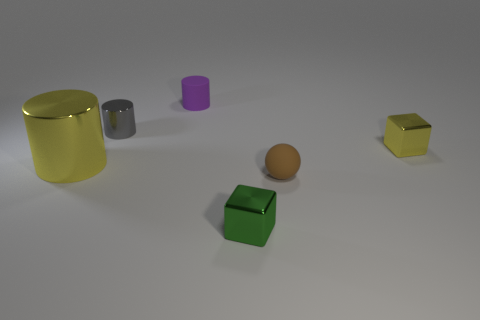Do the large thing and the tiny brown thing have the same shape? No, they do not share the same shape. The large object is cylindrical, likely a can or a barrel, with a curved surface and circular ends. On the other hand, the tiny brown object appears to be a spherical item, most probably a small ball. 